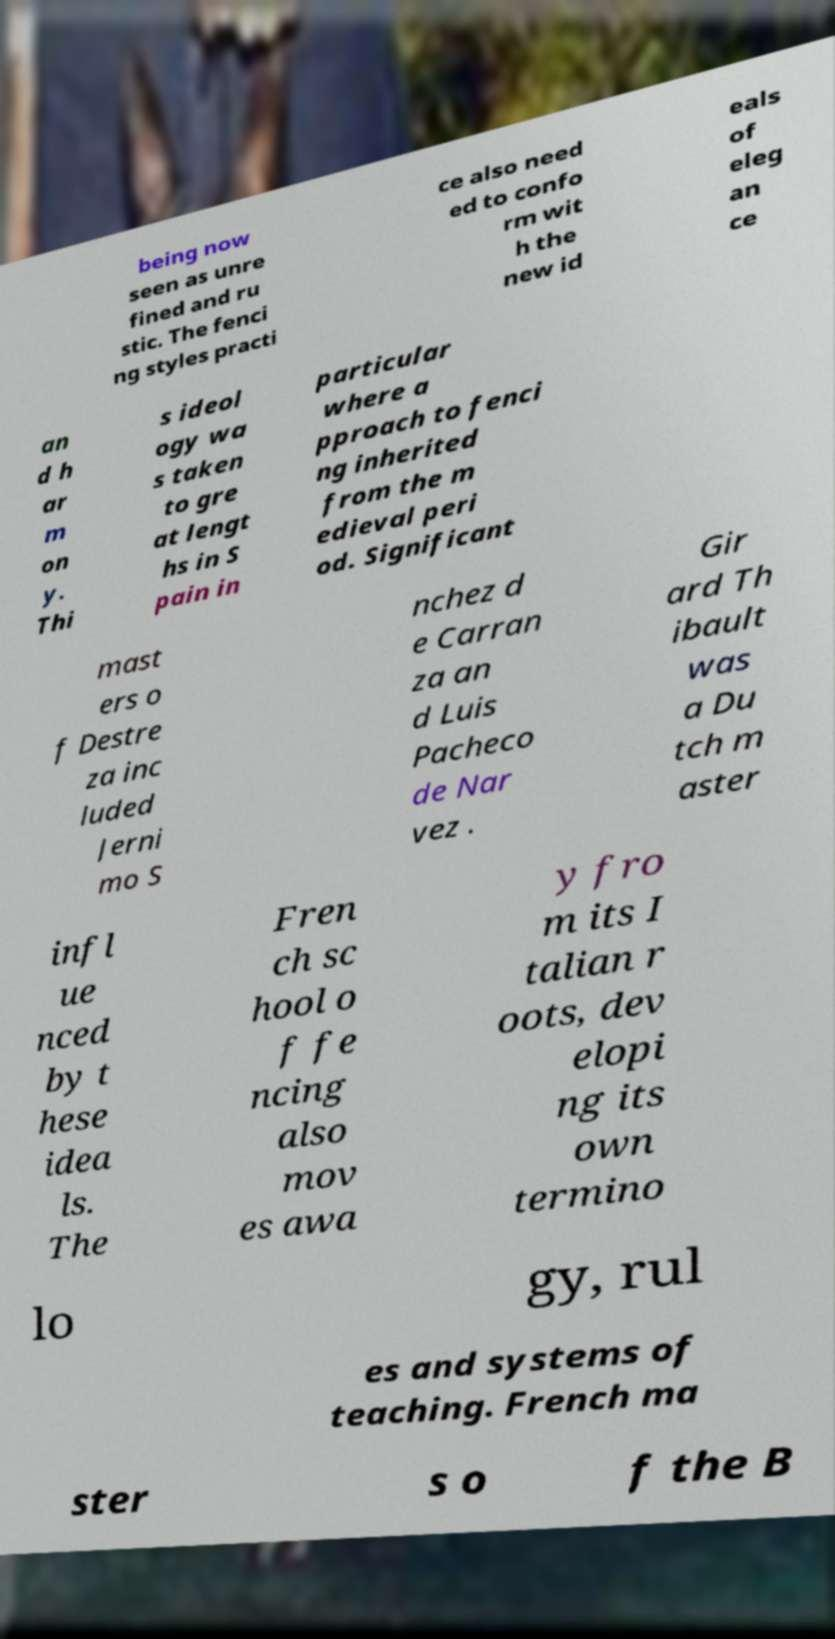I need the written content from this picture converted into text. Can you do that? being now seen as unre fined and ru stic. The fenci ng styles practi ce also need ed to confo rm wit h the new id eals of eleg an ce an d h ar m on y. Thi s ideol ogy wa s taken to gre at lengt hs in S pain in particular where a pproach to fenci ng inherited from the m edieval peri od. Significant mast ers o f Destre za inc luded Jerni mo S nchez d e Carran za an d Luis Pacheco de Nar vez . Gir ard Th ibault was a Du tch m aster infl ue nced by t hese idea ls. The Fren ch sc hool o f fe ncing also mov es awa y fro m its I talian r oots, dev elopi ng its own termino lo gy, rul es and systems of teaching. French ma ster s o f the B 